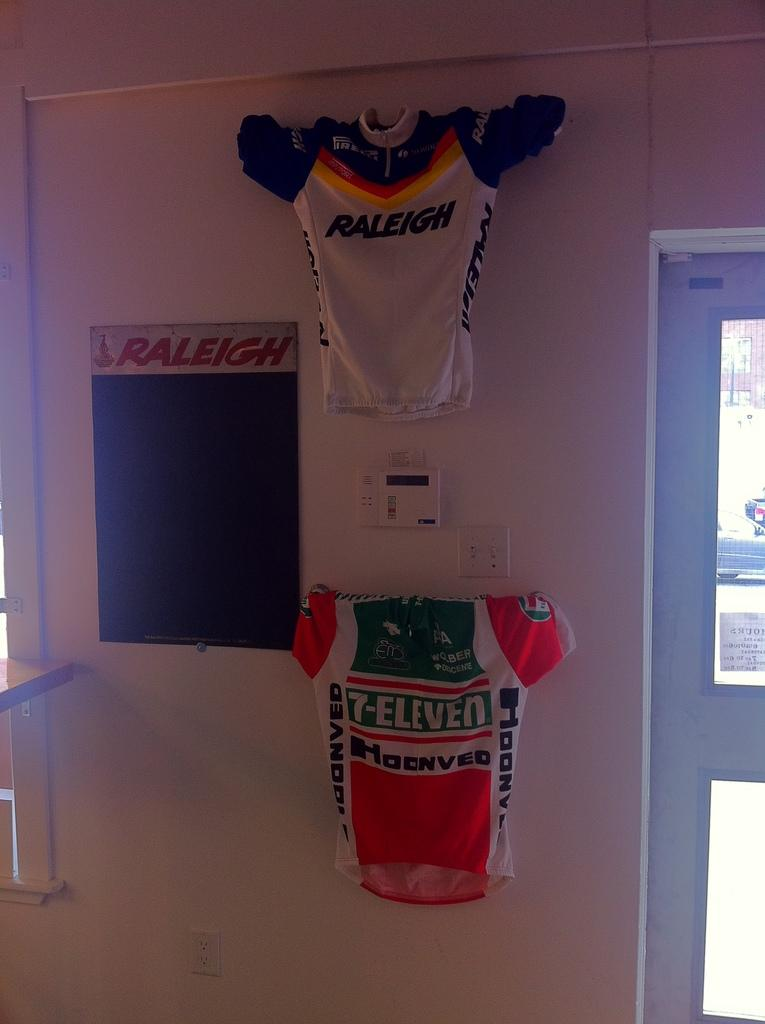<image>
Summarize the visual content of the image. Two jerseys hanging on a wall with one that says RALEIGH on it. 